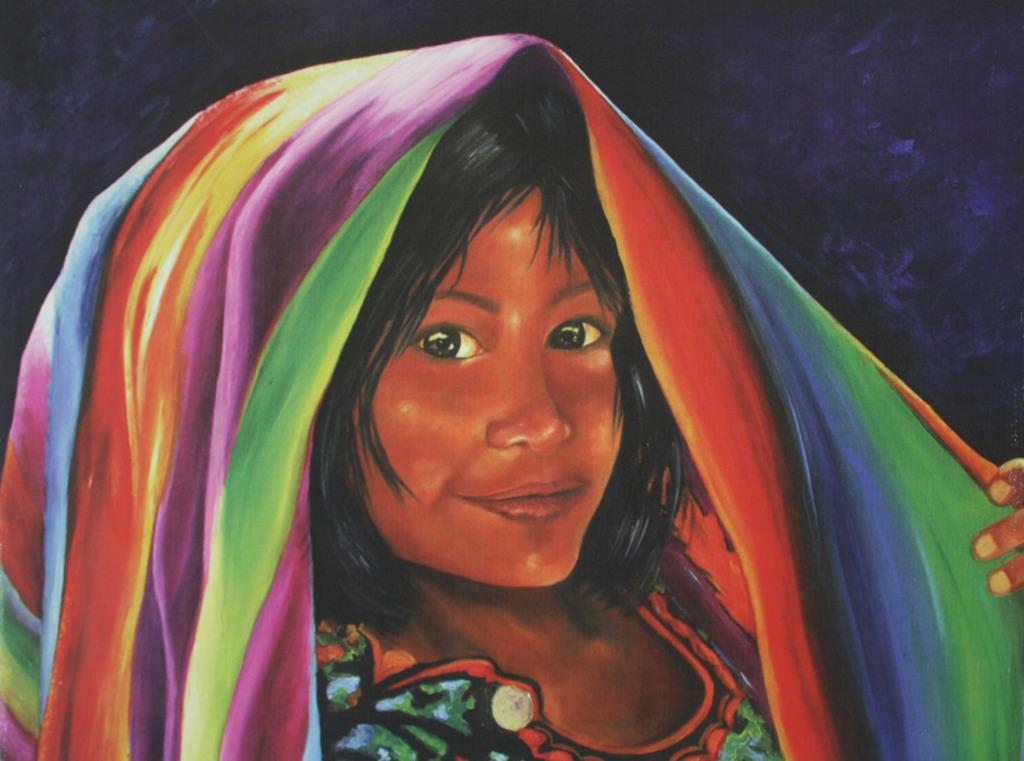What is the main subject of the image? There is a painting in the image. What is depicted in the painting? The painting depicts a person. What is the person in the painting wearing? The person in the painting is wearing a colorful dress. What colors are used in the background of the painting? The background of the painting is black and purple in color. What type of button can be seen on the hand of the person in the painting? There is no button visible on the hand of the person in the painting. What material is the frame of the painting made of? The provided facts do not mention the frame of the painting, so we cannot answer this question. 